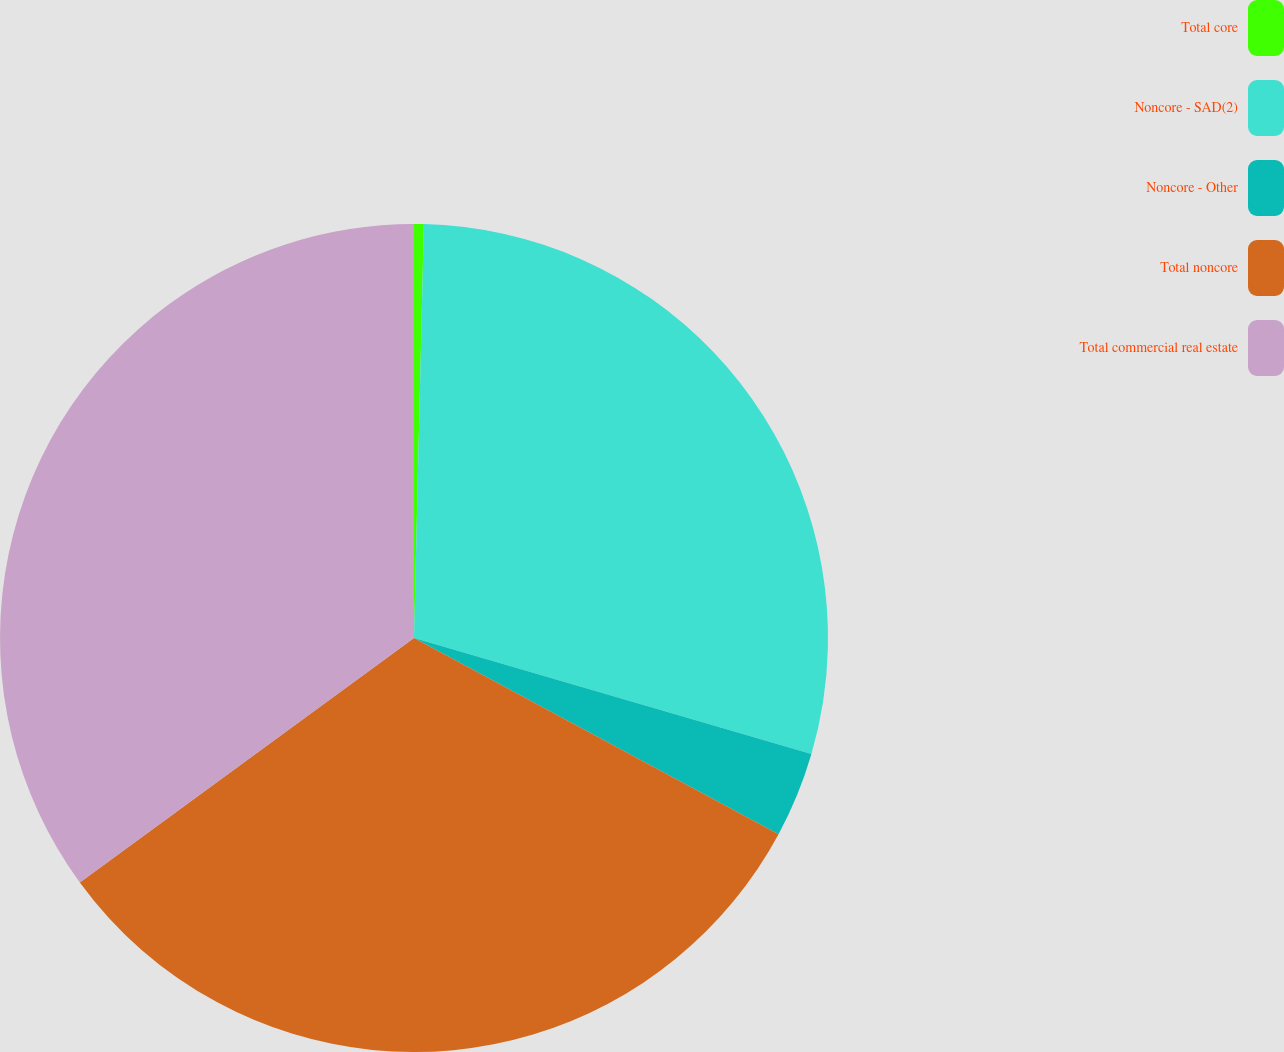<chart> <loc_0><loc_0><loc_500><loc_500><pie_chart><fcel>Total core<fcel>Noncore - SAD(2)<fcel>Noncore - Other<fcel>Total noncore<fcel>Total commercial real estate<nl><fcel>0.38%<fcel>29.14%<fcel>3.34%<fcel>32.09%<fcel>35.05%<nl></chart> 